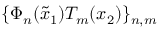<formula> <loc_0><loc_0><loc_500><loc_500>\{ \Phi _ { n } ( \tilde { x } _ { 1 } ) T _ { m } ( x _ { 2 } ) \} _ { n , m }</formula> 